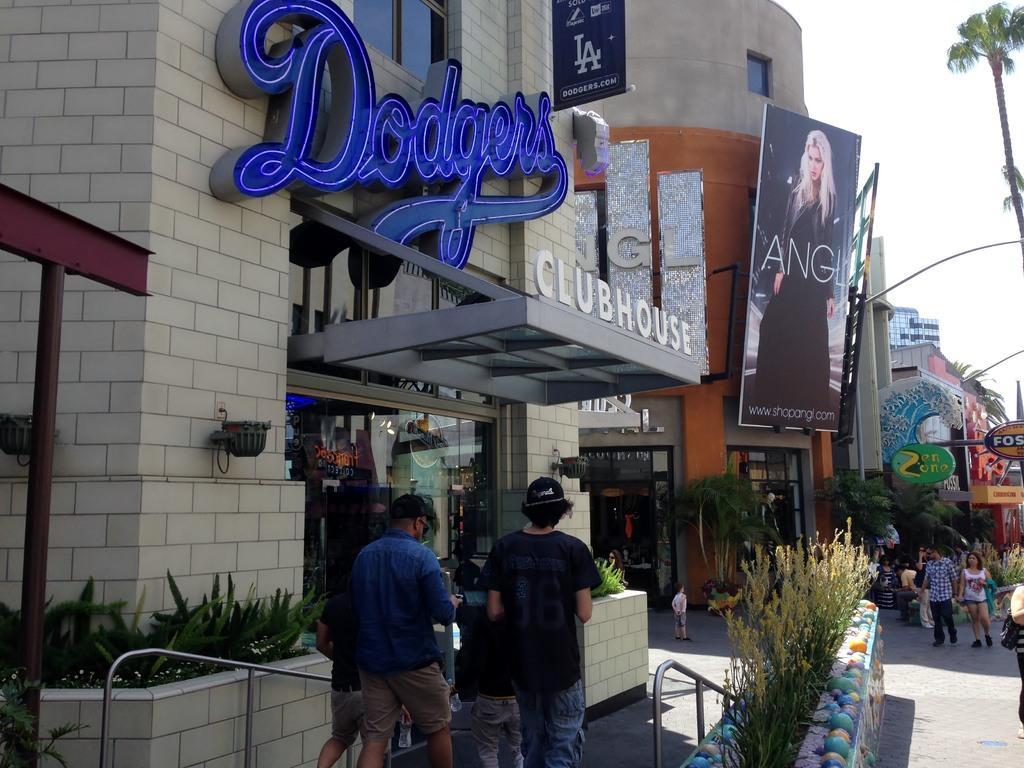How would you summarize this image in a sentence or two? In this image we can see a few people, there are buildings, plants, trees, there are boars with text on them, there are handrails, also we can see the sky. 